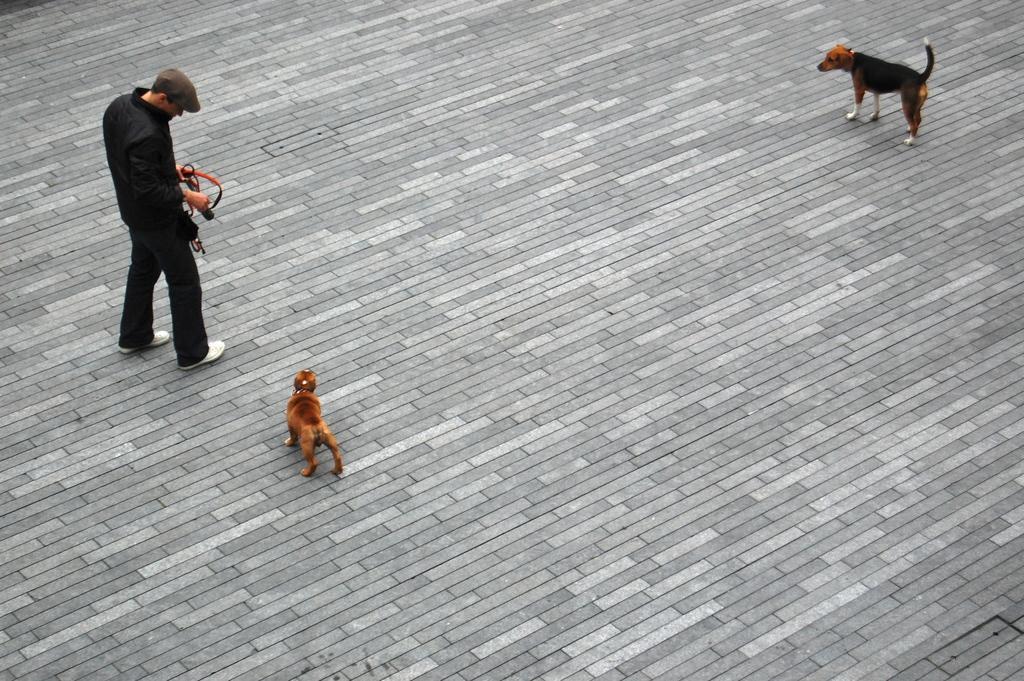Please provide a concise description of this image. In this image there is a person standing by holding some object in his hand, in front of the person there are two dogs. 